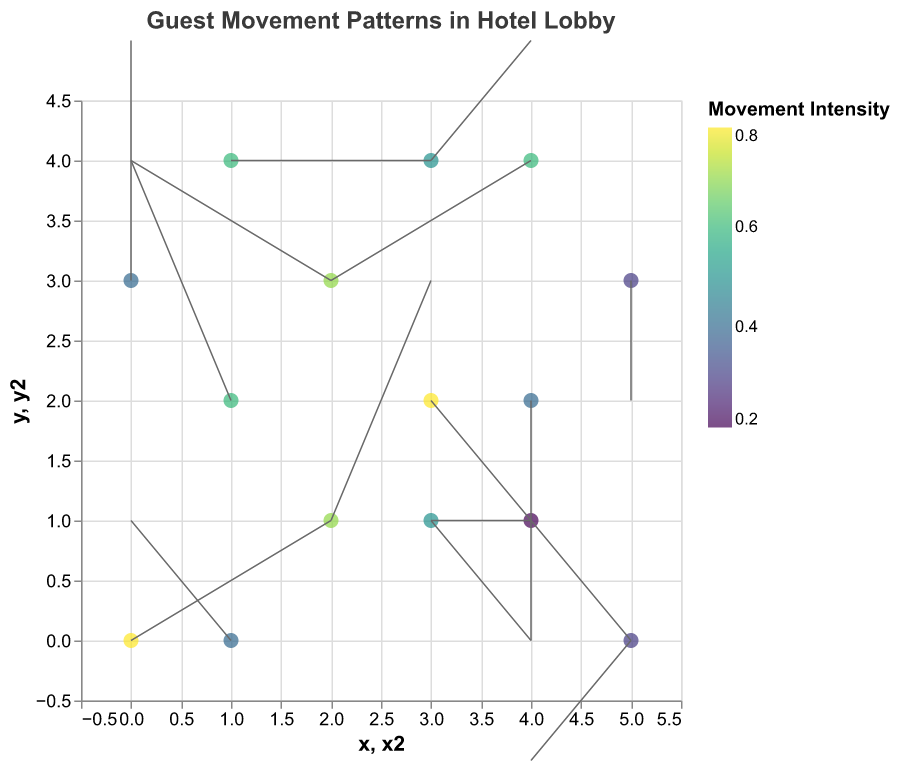What's the title of the figure? The title is usually placed at the top of the figure and is clear and descriptive.
Answer: Guest Movement Patterns in Hotel Lobby How many data points are there in the plot? Count the number of individual points shown on the plot.
Answer: 15 What is the range of the x-axis? Look at the minimum and maximum values indicated on the x-axis.
Answer: -0.5 to 5.5 Which point has the highest movement intensity (magnitude)? The color mapping represents the intensity; the point with the darkest color or highest numerical value has the highest intensity.
Answer: Point at (0,0) How many points have a non-zero vertical movement component (v)? Identify the points where the vertical component (v) is not zero by examining the arrows.
Answer: 12 Which direction does the point at (3, 4) move? Examine the direction of the arrow starting from (3, 4).
Answer: Upward to the right Compare the movement patterns for the points at (2,3) and (4,4). Which one has a higher magnitude? Look at both points' vectors and compare their magnitude values. The more intense color often correlates to a higher magnitude.
Answer: Point at (2,3) What is the average magnitude of all points? Sum up all the magnitude values and divide by the number of points (15). The sum is 7.2, making the average 7.2 / 15 = 0.48
Answer: 0.48 What is the overall trend of the movement towards the right (positive x-direction)? Identify and count the number of vectors moving right (positive x component u).
Answer: 7 points have a positive x-direction movement Is there any point that moves strictly vertically? Identify points where the movement vector has no horizontal component (u=0).
Answer: Yes, points at (0,3) and (4,4) 